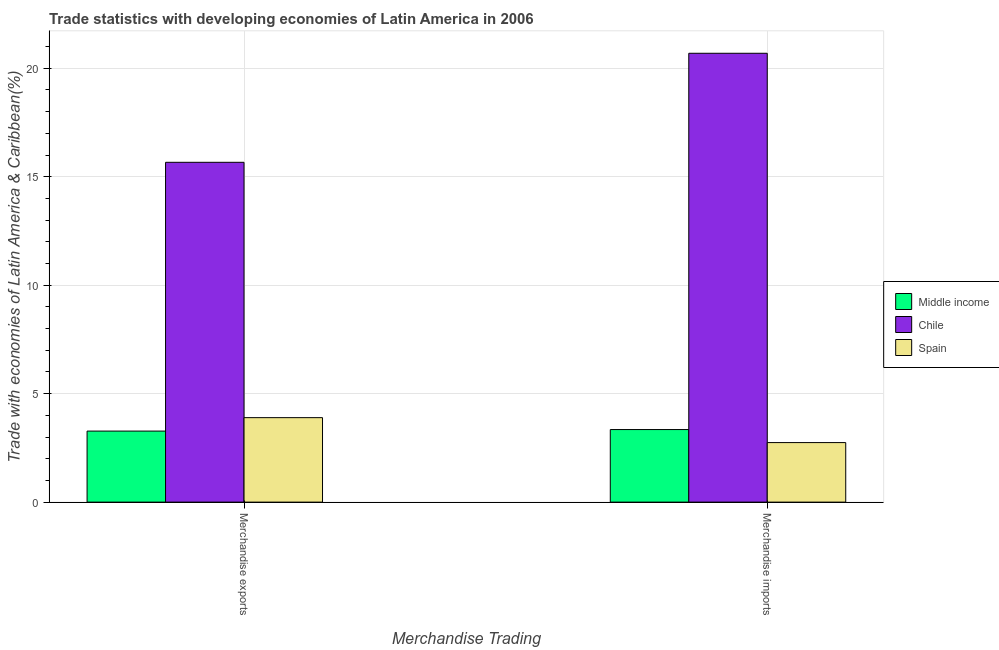How many different coloured bars are there?
Provide a succinct answer. 3. How many groups of bars are there?
Your answer should be very brief. 2. Are the number of bars on each tick of the X-axis equal?
Provide a succinct answer. Yes. How many bars are there on the 2nd tick from the left?
Offer a terse response. 3. How many bars are there on the 1st tick from the right?
Keep it short and to the point. 3. What is the merchandise exports in Chile?
Make the answer very short. 15.67. Across all countries, what is the maximum merchandise imports?
Your answer should be compact. 20.69. Across all countries, what is the minimum merchandise imports?
Ensure brevity in your answer.  2.75. What is the total merchandise exports in the graph?
Provide a succinct answer. 22.84. What is the difference between the merchandise imports in Spain and that in Middle income?
Offer a terse response. -0.6. What is the difference between the merchandise exports in Spain and the merchandise imports in Middle income?
Your answer should be compact. 0.55. What is the average merchandise imports per country?
Offer a very short reply. 8.93. What is the difference between the merchandise imports and merchandise exports in Spain?
Your response must be concise. -1.15. In how many countries, is the merchandise imports greater than 14 %?
Offer a very short reply. 1. What is the ratio of the merchandise exports in Chile to that in Middle income?
Keep it short and to the point. 4.78. Is the merchandise imports in Middle income less than that in Chile?
Provide a short and direct response. Yes. In how many countries, is the merchandise imports greater than the average merchandise imports taken over all countries?
Provide a succinct answer. 1. What does the 2nd bar from the left in Merchandise imports represents?
Offer a very short reply. Chile. Are all the bars in the graph horizontal?
Offer a very short reply. No. Are the values on the major ticks of Y-axis written in scientific E-notation?
Your response must be concise. No. Where does the legend appear in the graph?
Make the answer very short. Center right. How are the legend labels stacked?
Offer a terse response. Vertical. What is the title of the graph?
Keep it short and to the point. Trade statistics with developing economies of Latin America in 2006. What is the label or title of the X-axis?
Give a very brief answer. Merchandise Trading. What is the label or title of the Y-axis?
Your answer should be very brief. Trade with economies of Latin America & Caribbean(%). What is the Trade with economies of Latin America & Caribbean(%) in Middle income in Merchandise exports?
Offer a terse response. 3.27. What is the Trade with economies of Latin America & Caribbean(%) of Chile in Merchandise exports?
Provide a short and direct response. 15.67. What is the Trade with economies of Latin America & Caribbean(%) in Spain in Merchandise exports?
Provide a succinct answer. 3.89. What is the Trade with economies of Latin America & Caribbean(%) of Middle income in Merchandise imports?
Your answer should be very brief. 3.35. What is the Trade with economies of Latin America & Caribbean(%) in Chile in Merchandise imports?
Make the answer very short. 20.69. What is the Trade with economies of Latin America & Caribbean(%) in Spain in Merchandise imports?
Ensure brevity in your answer.  2.75. Across all Merchandise Trading, what is the maximum Trade with economies of Latin America & Caribbean(%) of Middle income?
Your answer should be compact. 3.35. Across all Merchandise Trading, what is the maximum Trade with economies of Latin America & Caribbean(%) of Chile?
Offer a terse response. 20.69. Across all Merchandise Trading, what is the maximum Trade with economies of Latin America & Caribbean(%) of Spain?
Give a very brief answer. 3.89. Across all Merchandise Trading, what is the minimum Trade with economies of Latin America & Caribbean(%) in Middle income?
Your answer should be compact. 3.27. Across all Merchandise Trading, what is the minimum Trade with economies of Latin America & Caribbean(%) in Chile?
Offer a very short reply. 15.67. Across all Merchandise Trading, what is the minimum Trade with economies of Latin America & Caribbean(%) of Spain?
Offer a terse response. 2.75. What is the total Trade with economies of Latin America & Caribbean(%) in Middle income in the graph?
Provide a succinct answer. 6.62. What is the total Trade with economies of Latin America & Caribbean(%) of Chile in the graph?
Ensure brevity in your answer.  36.36. What is the total Trade with economies of Latin America & Caribbean(%) of Spain in the graph?
Ensure brevity in your answer.  6.64. What is the difference between the Trade with economies of Latin America & Caribbean(%) of Middle income in Merchandise exports and that in Merchandise imports?
Your response must be concise. -0.07. What is the difference between the Trade with economies of Latin America & Caribbean(%) of Chile in Merchandise exports and that in Merchandise imports?
Provide a succinct answer. -5.03. What is the difference between the Trade with economies of Latin America & Caribbean(%) in Spain in Merchandise exports and that in Merchandise imports?
Keep it short and to the point. 1.15. What is the difference between the Trade with economies of Latin America & Caribbean(%) in Middle income in Merchandise exports and the Trade with economies of Latin America & Caribbean(%) in Chile in Merchandise imports?
Offer a terse response. -17.42. What is the difference between the Trade with economies of Latin America & Caribbean(%) of Middle income in Merchandise exports and the Trade with economies of Latin America & Caribbean(%) of Spain in Merchandise imports?
Keep it short and to the point. 0.53. What is the difference between the Trade with economies of Latin America & Caribbean(%) of Chile in Merchandise exports and the Trade with economies of Latin America & Caribbean(%) of Spain in Merchandise imports?
Your answer should be very brief. 12.92. What is the average Trade with economies of Latin America & Caribbean(%) of Middle income per Merchandise Trading?
Provide a succinct answer. 3.31. What is the average Trade with economies of Latin America & Caribbean(%) in Chile per Merchandise Trading?
Keep it short and to the point. 18.18. What is the average Trade with economies of Latin America & Caribbean(%) of Spain per Merchandise Trading?
Give a very brief answer. 3.32. What is the difference between the Trade with economies of Latin America & Caribbean(%) of Middle income and Trade with economies of Latin America & Caribbean(%) of Chile in Merchandise exports?
Give a very brief answer. -12.39. What is the difference between the Trade with economies of Latin America & Caribbean(%) of Middle income and Trade with economies of Latin America & Caribbean(%) of Spain in Merchandise exports?
Make the answer very short. -0.62. What is the difference between the Trade with economies of Latin America & Caribbean(%) in Chile and Trade with economies of Latin America & Caribbean(%) in Spain in Merchandise exports?
Your response must be concise. 11.77. What is the difference between the Trade with economies of Latin America & Caribbean(%) in Middle income and Trade with economies of Latin America & Caribbean(%) in Chile in Merchandise imports?
Provide a succinct answer. -17.35. What is the difference between the Trade with economies of Latin America & Caribbean(%) in Middle income and Trade with economies of Latin America & Caribbean(%) in Spain in Merchandise imports?
Keep it short and to the point. 0.6. What is the difference between the Trade with economies of Latin America & Caribbean(%) in Chile and Trade with economies of Latin America & Caribbean(%) in Spain in Merchandise imports?
Your answer should be compact. 17.95. What is the ratio of the Trade with economies of Latin America & Caribbean(%) in Middle income in Merchandise exports to that in Merchandise imports?
Offer a terse response. 0.98. What is the ratio of the Trade with economies of Latin America & Caribbean(%) in Chile in Merchandise exports to that in Merchandise imports?
Offer a terse response. 0.76. What is the ratio of the Trade with economies of Latin America & Caribbean(%) in Spain in Merchandise exports to that in Merchandise imports?
Your response must be concise. 1.42. What is the difference between the highest and the second highest Trade with economies of Latin America & Caribbean(%) of Middle income?
Offer a very short reply. 0.07. What is the difference between the highest and the second highest Trade with economies of Latin America & Caribbean(%) of Chile?
Give a very brief answer. 5.03. What is the difference between the highest and the second highest Trade with economies of Latin America & Caribbean(%) of Spain?
Offer a very short reply. 1.15. What is the difference between the highest and the lowest Trade with economies of Latin America & Caribbean(%) of Middle income?
Provide a succinct answer. 0.07. What is the difference between the highest and the lowest Trade with economies of Latin America & Caribbean(%) of Chile?
Offer a very short reply. 5.03. What is the difference between the highest and the lowest Trade with economies of Latin America & Caribbean(%) in Spain?
Give a very brief answer. 1.15. 